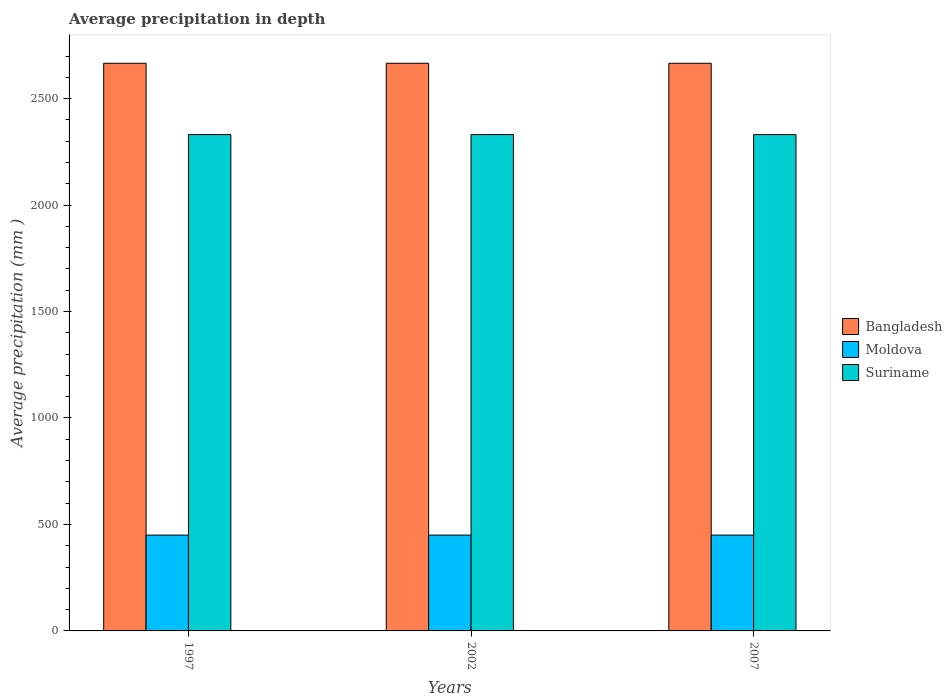How many different coloured bars are there?
Make the answer very short. 3. How many groups of bars are there?
Your response must be concise. 3. Are the number of bars on each tick of the X-axis equal?
Offer a very short reply. Yes. How many bars are there on the 2nd tick from the right?
Offer a terse response. 3. What is the label of the 2nd group of bars from the left?
Provide a succinct answer. 2002. What is the average precipitation in Suriname in 2007?
Provide a short and direct response. 2331. Across all years, what is the maximum average precipitation in Bangladesh?
Offer a very short reply. 2666. Across all years, what is the minimum average precipitation in Suriname?
Offer a terse response. 2331. What is the total average precipitation in Bangladesh in the graph?
Offer a terse response. 7998. What is the difference between the average precipitation in Moldova in 2007 and the average precipitation in Bangladesh in 2002?
Provide a succinct answer. -2216. What is the average average precipitation in Moldova per year?
Ensure brevity in your answer.  450. In the year 1997, what is the difference between the average precipitation in Bangladesh and average precipitation in Moldova?
Provide a short and direct response. 2216. In how many years, is the average precipitation in Moldova greater than 500 mm?
Provide a short and direct response. 0. What is the ratio of the average precipitation in Bangladesh in 1997 to that in 2002?
Your response must be concise. 1. Is the average precipitation in Suriname in 2002 less than that in 2007?
Provide a short and direct response. No. Is the difference between the average precipitation in Bangladesh in 1997 and 2002 greater than the difference between the average precipitation in Moldova in 1997 and 2002?
Offer a very short reply. No. What is the difference between the highest and the second highest average precipitation in Suriname?
Keep it short and to the point. 0. What does the 1st bar from the right in 2002 represents?
Ensure brevity in your answer.  Suriname. Are all the bars in the graph horizontal?
Give a very brief answer. No. Are the values on the major ticks of Y-axis written in scientific E-notation?
Your answer should be compact. No. Does the graph contain grids?
Your answer should be compact. No. Where does the legend appear in the graph?
Your response must be concise. Center right. How many legend labels are there?
Give a very brief answer. 3. What is the title of the graph?
Give a very brief answer. Average precipitation in depth. What is the label or title of the Y-axis?
Give a very brief answer. Average precipitation (mm ). What is the Average precipitation (mm ) in Bangladesh in 1997?
Make the answer very short. 2666. What is the Average precipitation (mm ) in Moldova in 1997?
Provide a succinct answer. 450. What is the Average precipitation (mm ) of Suriname in 1997?
Provide a succinct answer. 2331. What is the Average precipitation (mm ) of Bangladesh in 2002?
Give a very brief answer. 2666. What is the Average precipitation (mm ) in Moldova in 2002?
Ensure brevity in your answer.  450. What is the Average precipitation (mm ) of Suriname in 2002?
Ensure brevity in your answer.  2331. What is the Average precipitation (mm ) in Bangladesh in 2007?
Offer a very short reply. 2666. What is the Average precipitation (mm ) in Moldova in 2007?
Your answer should be compact. 450. What is the Average precipitation (mm ) in Suriname in 2007?
Your answer should be very brief. 2331. Across all years, what is the maximum Average precipitation (mm ) in Bangladesh?
Your answer should be very brief. 2666. Across all years, what is the maximum Average precipitation (mm ) in Moldova?
Your answer should be very brief. 450. Across all years, what is the maximum Average precipitation (mm ) of Suriname?
Your answer should be very brief. 2331. Across all years, what is the minimum Average precipitation (mm ) in Bangladesh?
Provide a short and direct response. 2666. Across all years, what is the minimum Average precipitation (mm ) in Moldova?
Keep it short and to the point. 450. Across all years, what is the minimum Average precipitation (mm ) of Suriname?
Ensure brevity in your answer.  2331. What is the total Average precipitation (mm ) in Bangladesh in the graph?
Your answer should be very brief. 7998. What is the total Average precipitation (mm ) in Moldova in the graph?
Provide a short and direct response. 1350. What is the total Average precipitation (mm ) in Suriname in the graph?
Your response must be concise. 6993. What is the difference between the Average precipitation (mm ) in Bangladesh in 1997 and that in 2002?
Ensure brevity in your answer.  0. What is the difference between the Average precipitation (mm ) of Suriname in 1997 and that in 2002?
Provide a succinct answer. 0. What is the difference between the Average precipitation (mm ) in Suriname in 1997 and that in 2007?
Your answer should be very brief. 0. What is the difference between the Average precipitation (mm ) in Bangladesh in 2002 and that in 2007?
Your answer should be very brief. 0. What is the difference between the Average precipitation (mm ) in Bangladesh in 1997 and the Average precipitation (mm ) in Moldova in 2002?
Offer a terse response. 2216. What is the difference between the Average precipitation (mm ) in Bangladesh in 1997 and the Average precipitation (mm ) in Suriname in 2002?
Your answer should be compact. 335. What is the difference between the Average precipitation (mm ) in Moldova in 1997 and the Average precipitation (mm ) in Suriname in 2002?
Provide a short and direct response. -1881. What is the difference between the Average precipitation (mm ) in Bangladesh in 1997 and the Average precipitation (mm ) in Moldova in 2007?
Your answer should be very brief. 2216. What is the difference between the Average precipitation (mm ) in Bangladesh in 1997 and the Average precipitation (mm ) in Suriname in 2007?
Your answer should be very brief. 335. What is the difference between the Average precipitation (mm ) in Moldova in 1997 and the Average precipitation (mm ) in Suriname in 2007?
Provide a succinct answer. -1881. What is the difference between the Average precipitation (mm ) in Bangladesh in 2002 and the Average precipitation (mm ) in Moldova in 2007?
Offer a terse response. 2216. What is the difference between the Average precipitation (mm ) of Bangladesh in 2002 and the Average precipitation (mm ) of Suriname in 2007?
Your answer should be very brief. 335. What is the difference between the Average precipitation (mm ) in Moldova in 2002 and the Average precipitation (mm ) in Suriname in 2007?
Offer a terse response. -1881. What is the average Average precipitation (mm ) in Bangladesh per year?
Give a very brief answer. 2666. What is the average Average precipitation (mm ) of Moldova per year?
Give a very brief answer. 450. What is the average Average precipitation (mm ) in Suriname per year?
Make the answer very short. 2331. In the year 1997, what is the difference between the Average precipitation (mm ) in Bangladesh and Average precipitation (mm ) in Moldova?
Your response must be concise. 2216. In the year 1997, what is the difference between the Average precipitation (mm ) of Bangladesh and Average precipitation (mm ) of Suriname?
Provide a succinct answer. 335. In the year 1997, what is the difference between the Average precipitation (mm ) of Moldova and Average precipitation (mm ) of Suriname?
Make the answer very short. -1881. In the year 2002, what is the difference between the Average precipitation (mm ) of Bangladesh and Average precipitation (mm ) of Moldova?
Your answer should be very brief. 2216. In the year 2002, what is the difference between the Average precipitation (mm ) in Bangladesh and Average precipitation (mm ) in Suriname?
Offer a very short reply. 335. In the year 2002, what is the difference between the Average precipitation (mm ) in Moldova and Average precipitation (mm ) in Suriname?
Ensure brevity in your answer.  -1881. In the year 2007, what is the difference between the Average precipitation (mm ) of Bangladesh and Average precipitation (mm ) of Moldova?
Provide a succinct answer. 2216. In the year 2007, what is the difference between the Average precipitation (mm ) in Bangladesh and Average precipitation (mm ) in Suriname?
Make the answer very short. 335. In the year 2007, what is the difference between the Average precipitation (mm ) in Moldova and Average precipitation (mm ) in Suriname?
Your response must be concise. -1881. What is the ratio of the Average precipitation (mm ) in Moldova in 1997 to that in 2002?
Keep it short and to the point. 1. What is the ratio of the Average precipitation (mm ) of Suriname in 1997 to that in 2002?
Your answer should be compact. 1. What is the ratio of the Average precipitation (mm ) in Bangladesh in 1997 to that in 2007?
Ensure brevity in your answer.  1. What is the ratio of the Average precipitation (mm ) of Bangladesh in 2002 to that in 2007?
Offer a very short reply. 1. What is the ratio of the Average precipitation (mm ) of Moldova in 2002 to that in 2007?
Offer a terse response. 1. What is the ratio of the Average precipitation (mm ) of Suriname in 2002 to that in 2007?
Give a very brief answer. 1. What is the difference between the highest and the lowest Average precipitation (mm ) of Moldova?
Make the answer very short. 0. What is the difference between the highest and the lowest Average precipitation (mm ) in Suriname?
Your response must be concise. 0. 